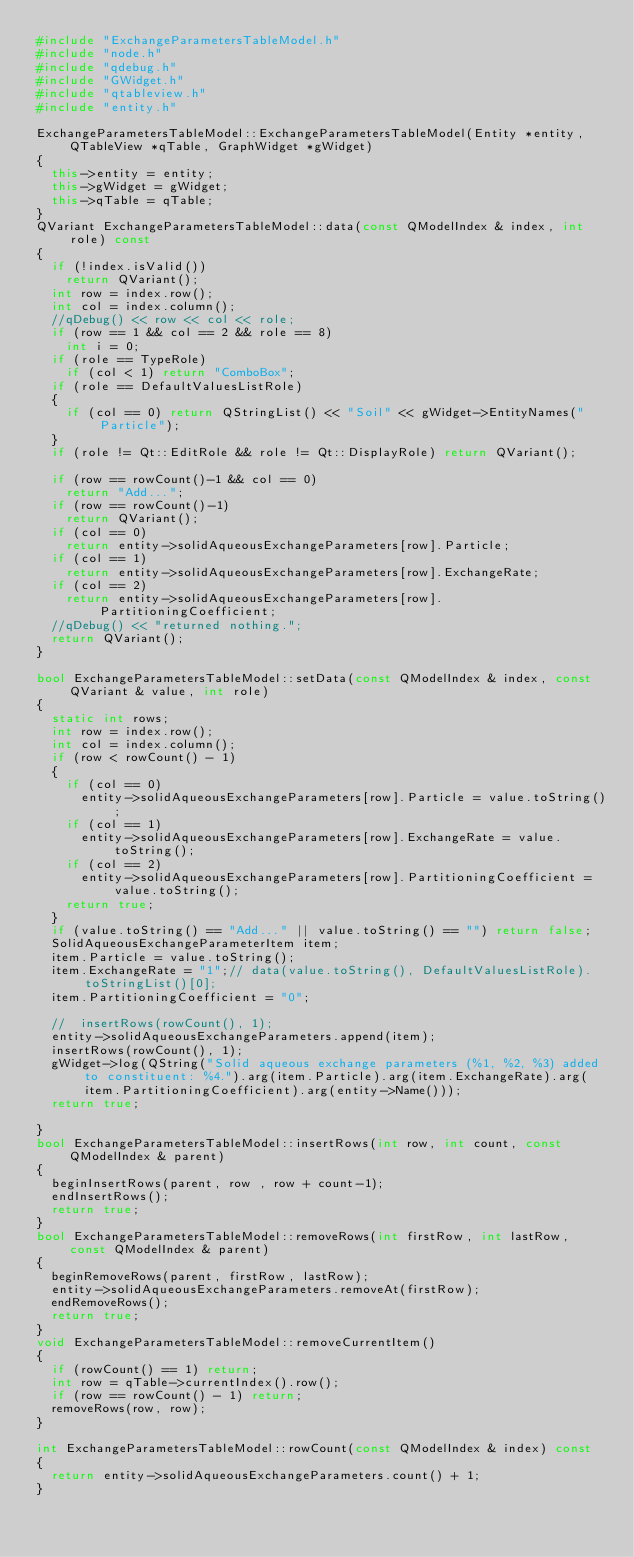<code> <loc_0><loc_0><loc_500><loc_500><_C++_>#include "ExchangeParametersTableModel.h"
#include "node.h"
#include "qdebug.h"
#include "GWidget.h"
#include "qtableview.h"
#include "entity.h"

ExchangeParametersTableModel::ExchangeParametersTableModel(Entity *entity, QTableView *qTable, GraphWidget *gWidget)
{
	this->entity = entity;
	this->gWidget = gWidget;
	this->qTable = qTable;
}
QVariant ExchangeParametersTableModel::data(const QModelIndex & index, int role) const
{
	if (!index.isValid())
		return QVariant();
	int row = index.row();
	int col = index.column();
	//qDebug() << row << col << role;
	if (row == 1 && col == 2 && role == 8)
		int i = 0;
	if (role == TypeRole)
		if (col < 1) return "ComboBox";
	if (role == DefaultValuesListRole)
	{
		if (col == 0) return QStringList() << "Soil" << gWidget->EntityNames("Particle");
	}
	if (role != Qt::EditRole && role != Qt::DisplayRole) return QVariant();

	if (row == rowCount()-1 && col == 0)
		return "Add...";
	if (row == rowCount()-1)
		return QVariant();
	if (col == 0)
		return entity->solidAqueousExchangeParameters[row].Particle;
	if (col == 1)
		return entity->solidAqueousExchangeParameters[row].ExchangeRate;
	if (col == 2)
		return entity->solidAqueousExchangeParameters[row].PartitioningCoefficient;
	//qDebug() << "returned nothing.";
	return QVariant();
}

bool ExchangeParametersTableModel::setData(const QModelIndex & index, const QVariant & value, int role)
{
	static int rows;
	int row = index.row();
	int col = index.column();
	if (row < rowCount() - 1)
	{
		if (col == 0)
			entity->solidAqueousExchangeParameters[row].Particle = value.toString();
		if (col == 1)
			entity->solidAqueousExchangeParameters[row].ExchangeRate = value.toString();
		if (col == 2)
			entity->solidAqueousExchangeParameters[row].PartitioningCoefficient = value.toString();
		return true;
	}
	if (value.toString() == "Add..." || value.toString() == "") return false;
	SolidAqueousExchangeParameterItem item;
	item.Particle = value.toString();
	item.ExchangeRate = "1";// data(value.toString(), DefaultValuesListRole).toStringList()[0];
	item.PartitioningCoefficient = "0";

	//	insertRows(rowCount(), 1);
	entity->solidAqueousExchangeParameters.append(item);
	insertRows(rowCount(), 1);
	gWidget->log(QString("Solid aqueous exchange parameters (%1, %2, %3) added to constituent: %4.").arg(item.Particle).arg(item.ExchangeRate).arg(item.PartitioningCoefficient).arg(entity->Name()));
	return true;

}
bool ExchangeParametersTableModel::insertRows(int row, int count, const QModelIndex & parent)
{
	beginInsertRows(parent, row , row + count-1);
	endInsertRows();
	return true;
}
bool ExchangeParametersTableModel::removeRows(int firstRow, int lastRow, const QModelIndex & parent)
{
	beginRemoveRows(parent, firstRow, lastRow);
	entity->solidAqueousExchangeParameters.removeAt(firstRow);
	endRemoveRows();
	return true;
}
void ExchangeParametersTableModel::removeCurrentItem()
{
	if (rowCount() == 1) return;
	int row = qTable->currentIndex().row();
	if (row == rowCount() - 1) return;
	removeRows(row, row);
}

int ExchangeParametersTableModel::rowCount(const QModelIndex & index) const
{
	return entity->solidAqueousExchangeParameters.count() + 1;
}
</code> 